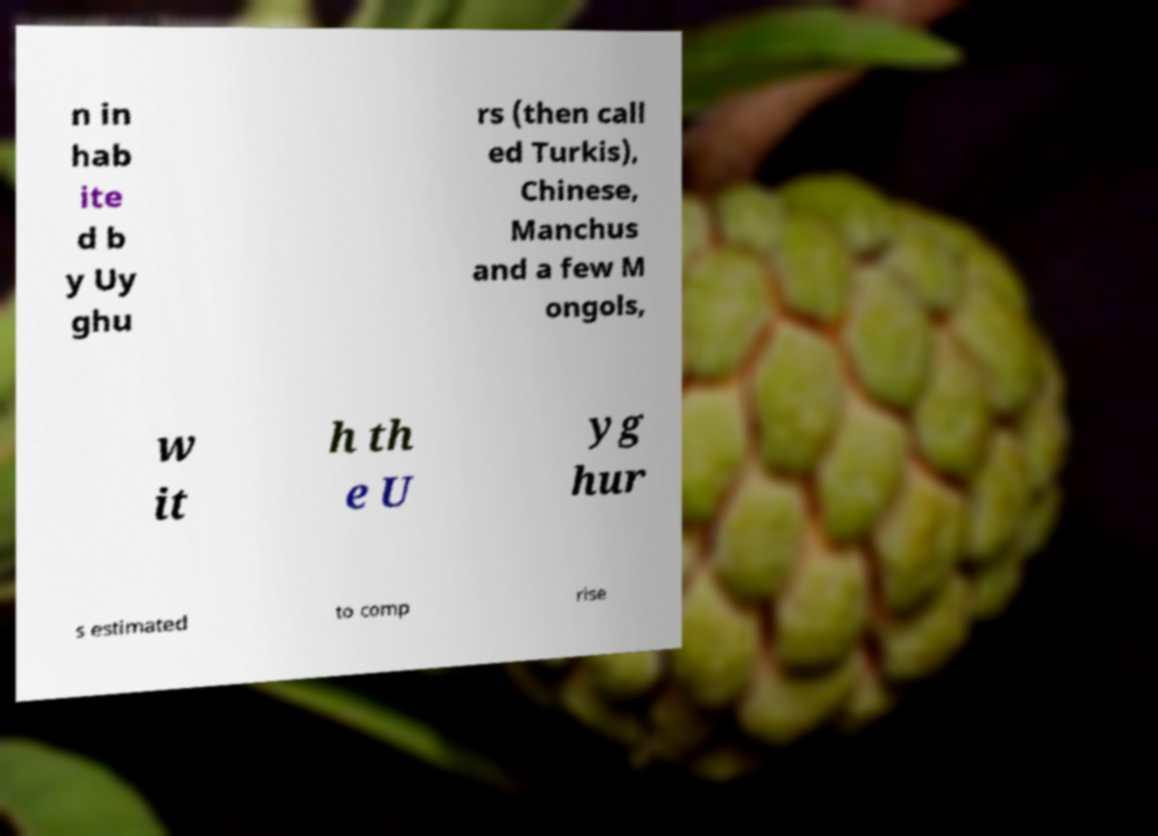Can you read and provide the text displayed in the image?This photo seems to have some interesting text. Can you extract and type it out for me? n in hab ite d b y Uy ghu rs (then call ed Turkis), Chinese, Manchus and a few M ongols, w it h th e U yg hur s estimated to comp rise 